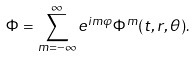<formula> <loc_0><loc_0><loc_500><loc_500>\Phi = \sum _ { m = - \infty } ^ { \infty } e ^ { i m \varphi } \Phi ^ { m } ( t , r , \theta ) .</formula> 